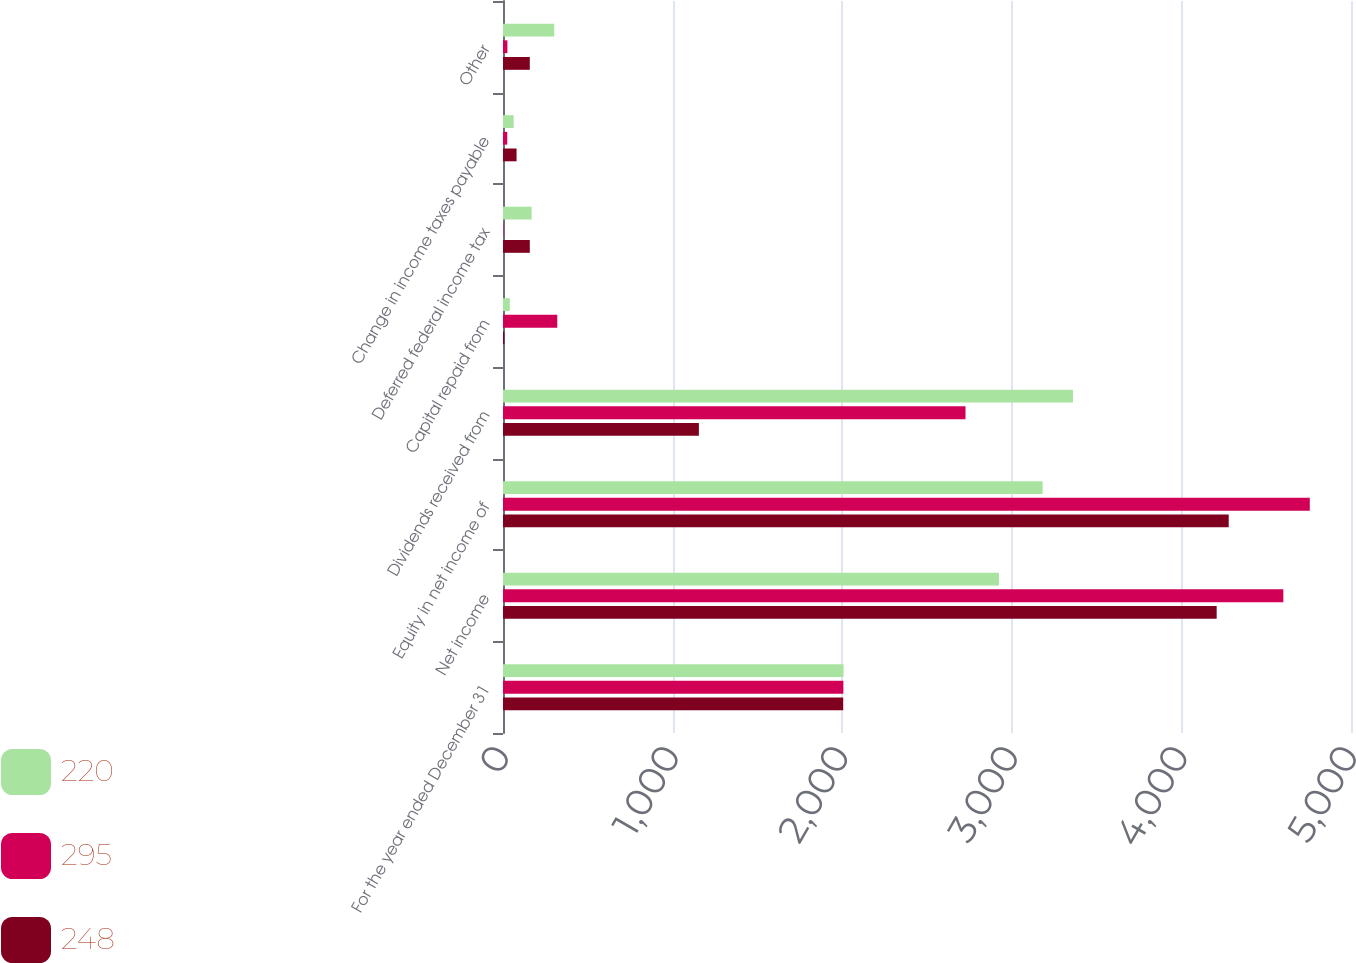Convert chart to OTSL. <chart><loc_0><loc_0><loc_500><loc_500><stacked_bar_chart><ecel><fcel>For the year ended December 31<fcel>Net income<fcel>Equity in net income of<fcel>Dividends received from<fcel>Capital repaid from<fcel>Deferred federal income tax<fcel>Change in income taxes payable<fcel>Other<nl><fcel>220<fcel>2008<fcel>2924<fcel>3182<fcel>3361<fcel>40<fcel>169<fcel>63<fcel>302<nl><fcel>295<fcel>2007<fcel>4601<fcel>4757<fcel>2727<fcel>320<fcel>2<fcel>25<fcel>26<nl><fcel>248<fcel>2006<fcel>4208<fcel>4279<fcel>1155<fcel>8<fcel>158<fcel>80<fcel>158<nl></chart> 